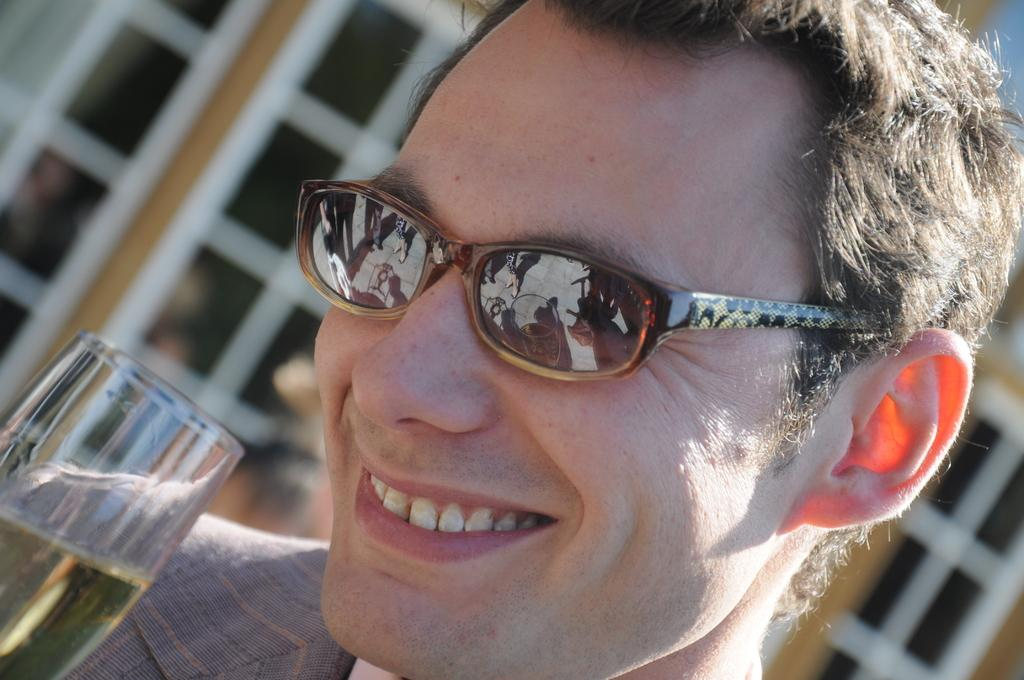What is present in the image? There is a man and a beverage glass in the image. Can you describe the man in the image? The facts provided do not give any specific details about the man's appearance or actions. What is the beverage glass used for? The facts provided do not specify the contents of the beverage glass. Is the squirrel stuck in the quicksand in the image? There is no squirrel or quicksand present in the image. Where is the sink located in the image? There is no sink present in the image. 